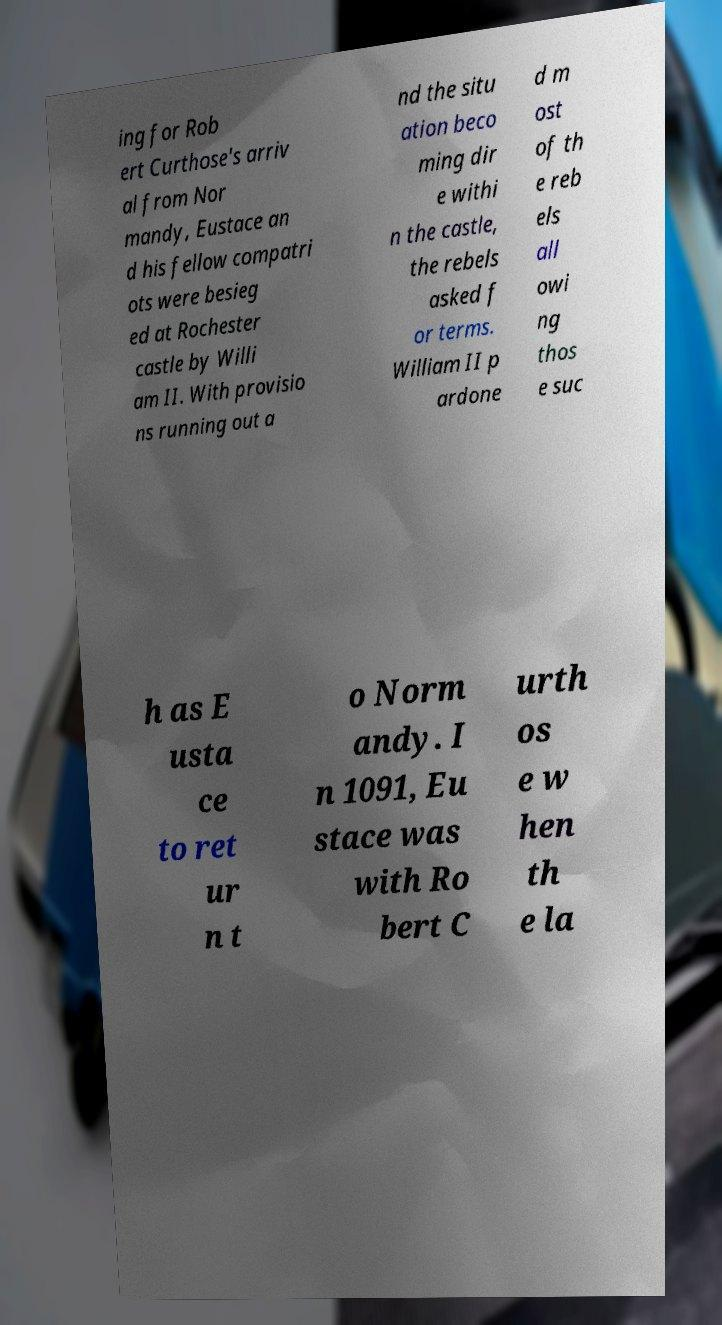Could you extract and type out the text from this image? ing for Rob ert Curthose's arriv al from Nor mandy, Eustace an d his fellow compatri ots were besieg ed at Rochester castle by Willi am II. With provisio ns running out a nd the situ ation beco ming dir e withi n the castle, the rebels asked f or terms. William II p ardone d m ost of th e reb els all owi ng thos e suc h as E usta ce to ret ur n t o Norm andy. I n 1091, Eu stace was with Ro bert C urth os e w hen th e la 